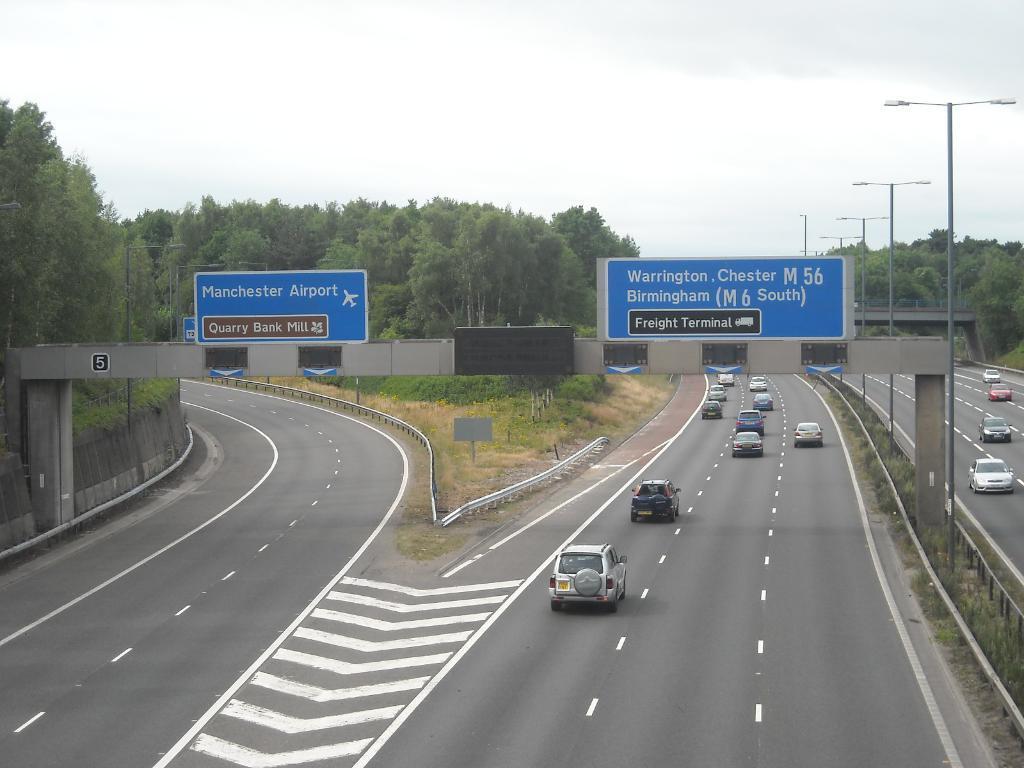Describe this image in one or two sentences. At the bottom of the image on the road there are few vehicles. Behind the road there is fencing. Behind the fencing there's grass on the ground. In front of the image there are poles with sign boards. And in the image there are many trees. On the right side of the image, on the road there are vehicles. At the top of the image there is sky. 